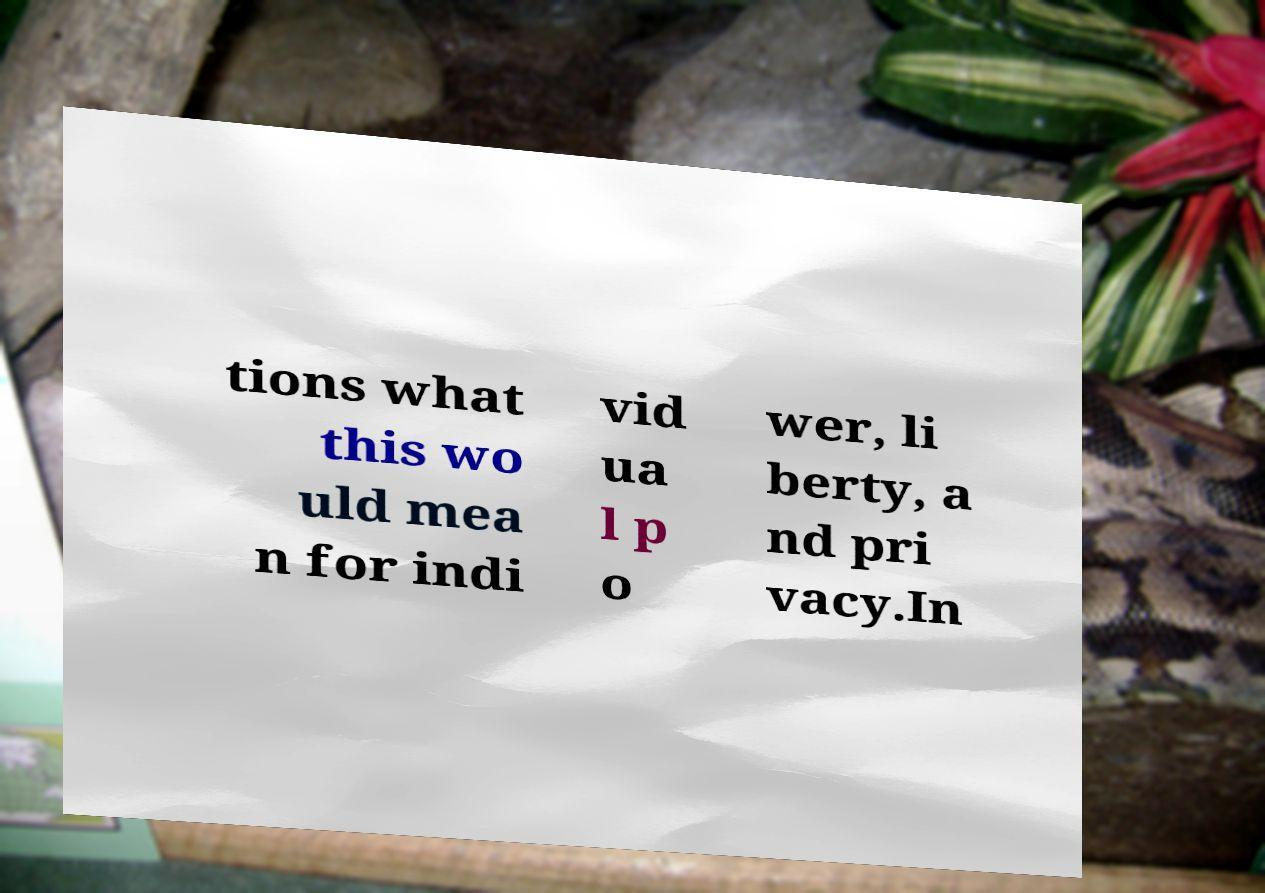I need the written content from this picture converted into text. Can you do that? tions what this wo uld mea n for indi vid ua l p o wer, li berty, a nd pri vacy.In 